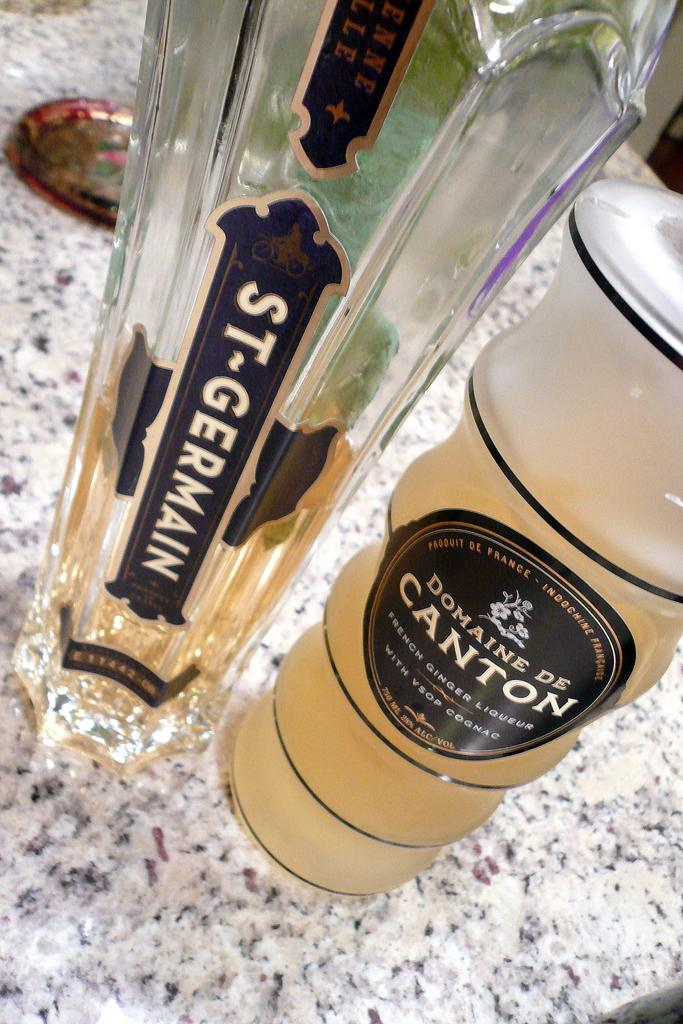What is on the bottle in the image? There is a sticker on the bottle in the image. What is in the glass in the image? There is a drink in the glass in the image. Where are the bottle and glass located in the image? The bottle and glass are placed on the floor in the image. What else can be seen in the background of the image? There are plates visible in the background of the image. What type of lead is being used to create the sticker on the bottle? There is no information about the type of lead used to create the sticker on the bottle, as the focus is on the presence of the sticker and not the materials used to make it. 